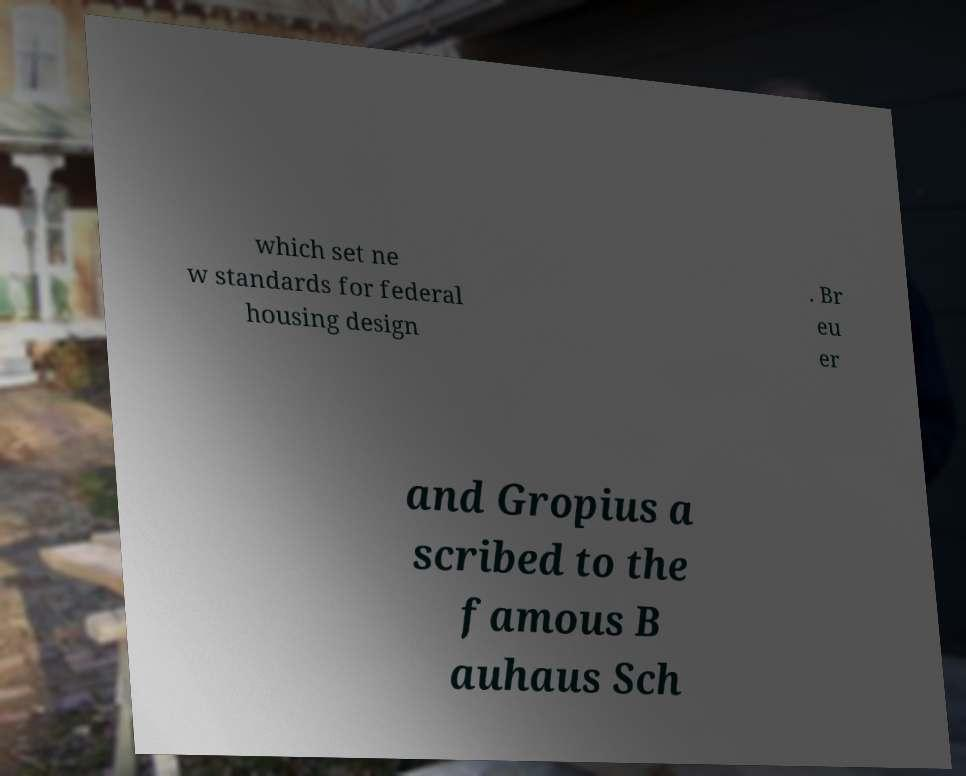Please read and relay the text visible in this image. What does it say? which set ne w standards for federal housing design . Br eu er and Gropius a scribed to the famous B auhaus Sch 